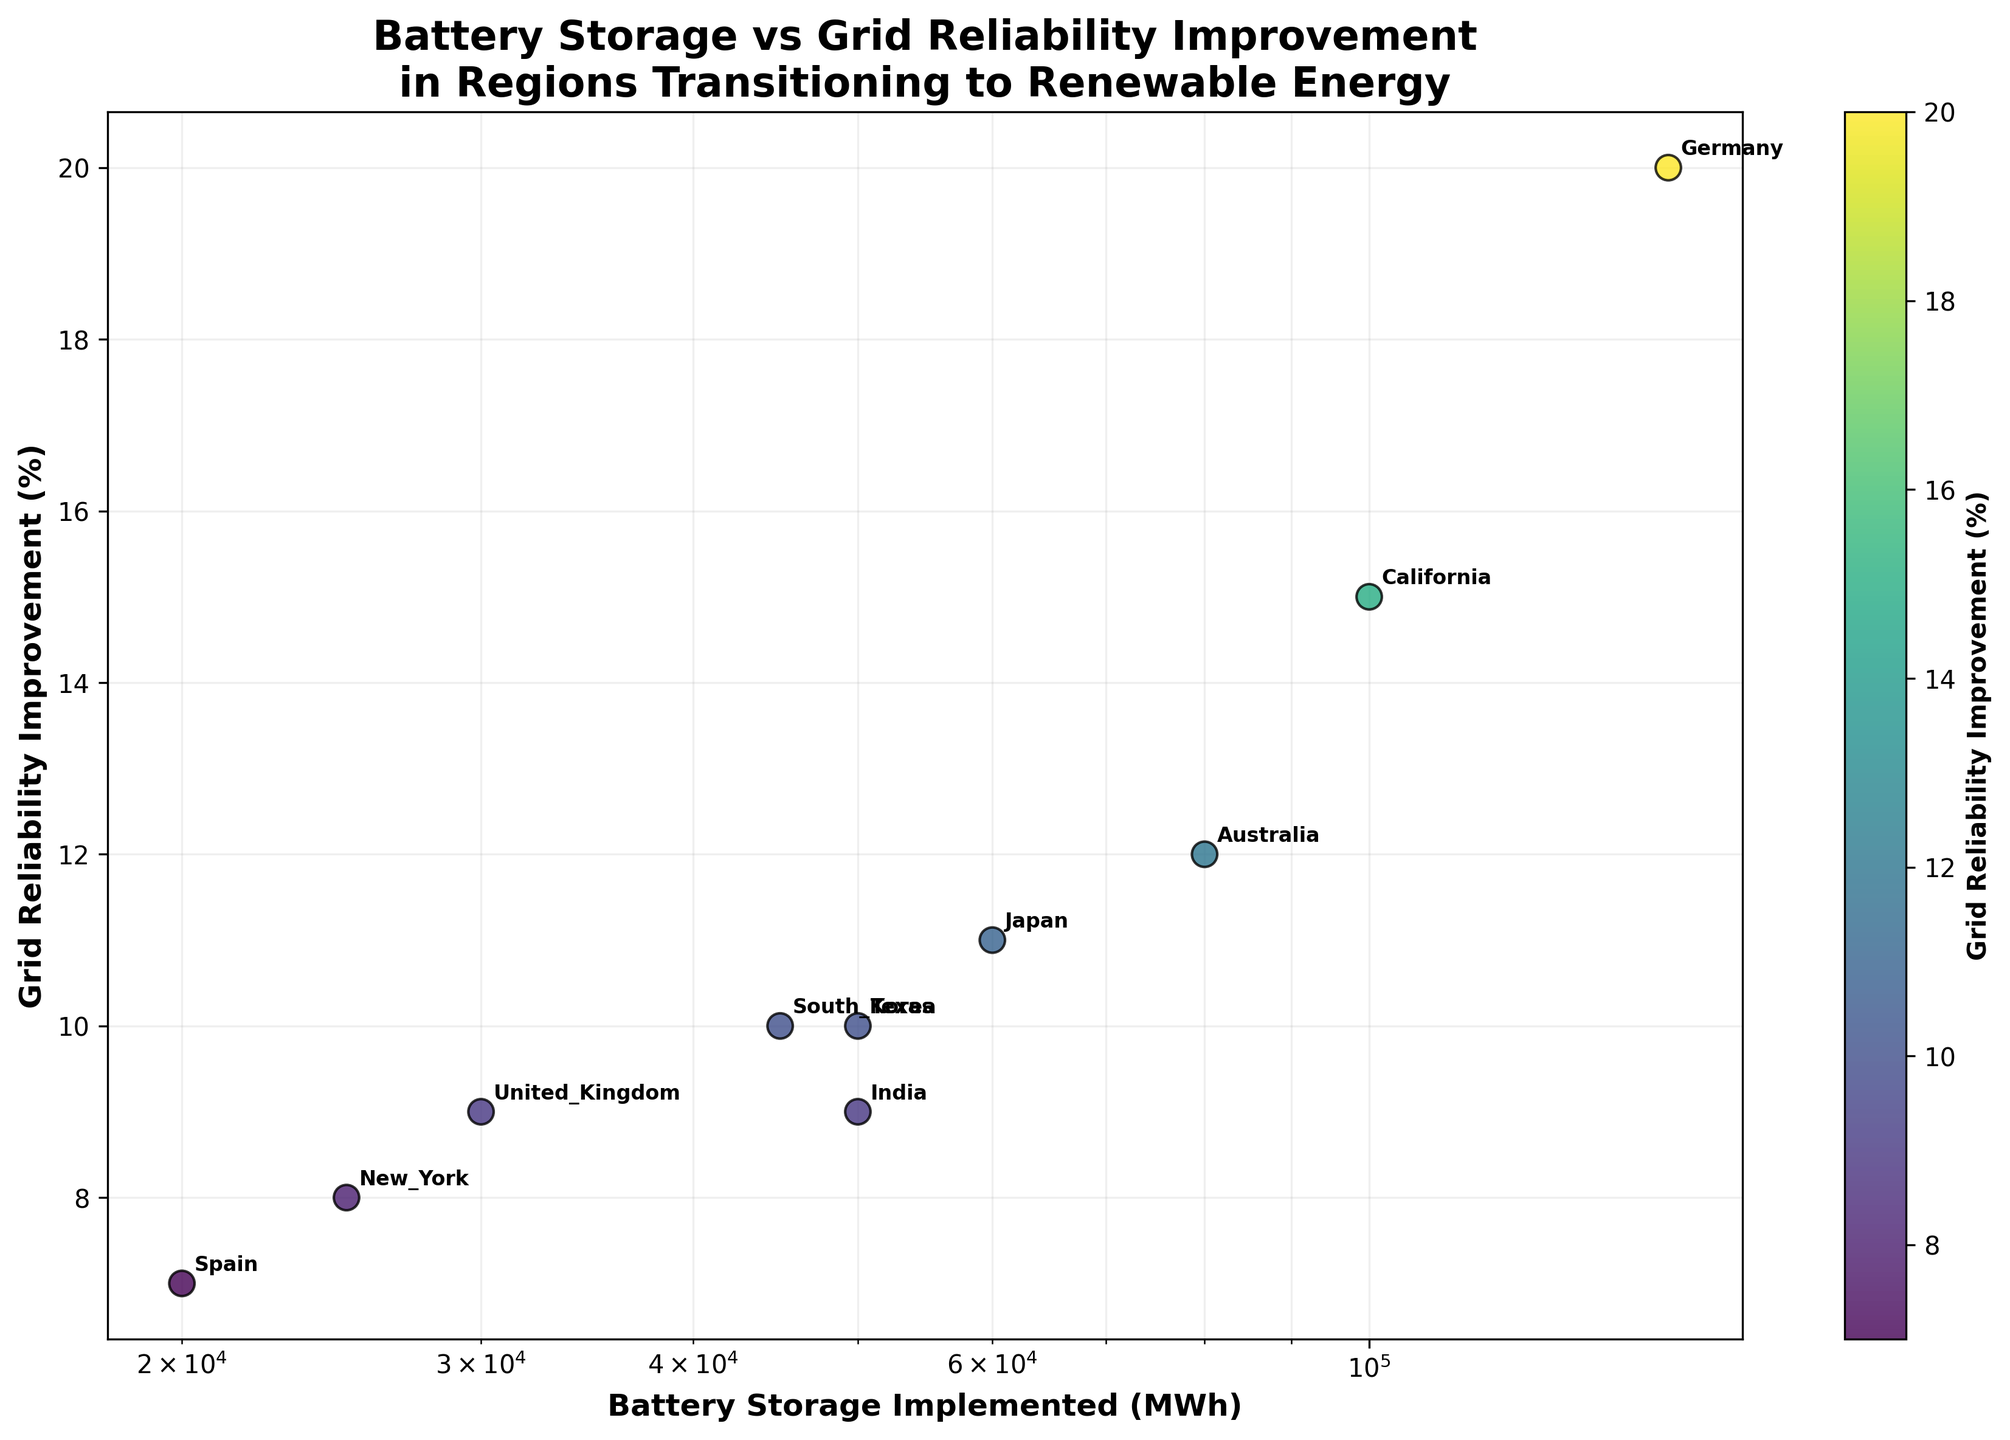How many regions are displayed in the figure? To find the number of regions displayed, count the number of distinct data points or annotations on the scatter plot. Each point or annotation represents one region.
Answer: 10 Which region has implemented the highest amount of battery storage? Locate the data point farthest to the right on the x-axis (Battery Storage Implemented). The annotation next to this point will indicate the region.
Answer: Germany What is the grid reliability improvement percentage for Texas? Identify the data point annotated with "Texas". Trace horizontally from this point to the y-axis to read the percentage.
Answer: 10% Compare the grid reliability improvement percentages of California and New York. Which is higher and by how much? Find the data points for California and New York. The percentage for California is higher. Calculate the difference by subtracting New York's percentage from California's.
Answer: California by 7% What's the average grid reliability improvement percentage for all regions? Sum the grid reliability improvement percentages for all regions: 15 + 10 + 8 + 20 + 12 + 9 + 11 + 10 + 7 + 9. Then, divide the total by the number of regions (10). (15 + 10 + 8 + 20 + 12 + 9 + 11 + 10 + 7 + 9) / 10 = 111 / 10
Answer: 11.1% Identify the relationship between battery storage implementation and grid reliability improvement. Is there a clear trend? Observe the scatter plot to see if there is a noticeable pattern. Notice that as battery storage increases, grid reliability tends to improve, but the trend is not perfectly linear due to variations in data points.
Answer: Positive correlation Which regions have a grid reliability improvement percentage of exactly 10%? Identify the data points on the y-axis at 10%. The regions annotated for these points are Texas and South Korea.
Answer: Texas, South Korea Is there any region with a grid reliability improvement percentage less than 8%? Find any data points below the 8% mark on the y-axis. There is one such point. The annotation next to this point will indicate the region.
Answer: Spain with 7% What is the median value of grid reliability improvement percentages? Arrange all grid reliability improvement percentages in ascending order: 7, 8, 9, 9, 10, 10, 11, 12, 15, 20. The median is the middle value for an even number of observations: (10 + 10) / 2.
Answer: 10% Which region has the lowest amount of battery storage implemented? Locate the data point farthest to the left on the x-axis (Battery Storage Implemented). The annotation next to this point will indicate the region.
Answer: Spain 